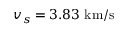<formula> <loc_0><loc_0><loc_500><loc_500>v _ { s } = 3 . 8 3 k m / s</formula> 